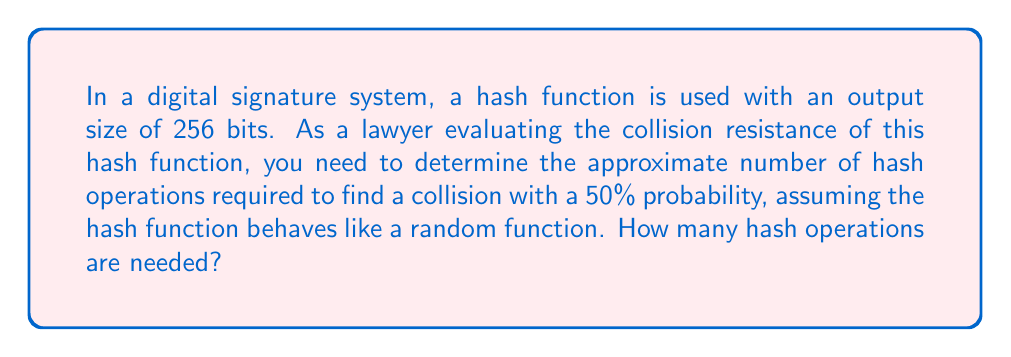Can you solve this math problem? To solve this problem, we need to understand the birthday paradox and its application to hash collision resistance. Here's a step-by-step explanation:

1. The birthday paradox states that for a hash function with an n-bit output, the probability of finding a collision after trying approximately $2^{n/2}$ inputs is about 50%.

2. In this case, we have a 256-bit hash function. So, n = 256.

3. To find the number of hash operations needed for a 50% probability of collision, we use the formula:

   $$\text{Number of operations} \approx 2^{n/2}$$

4. Substituting n = 256:

   $$\text{Number of operations} \approx 2^{256/2} = 2^{128}$$

5. $2^{128}$ is an extremely large number, approximately equal to $3.4 \times 10^{38}$.

This large number of required operations demonstrates the strong collision resistance of a 256-bit hash function, which is crucial for the security of digital signatures in legal contexts.
Answer: $2^{128}$ operations 